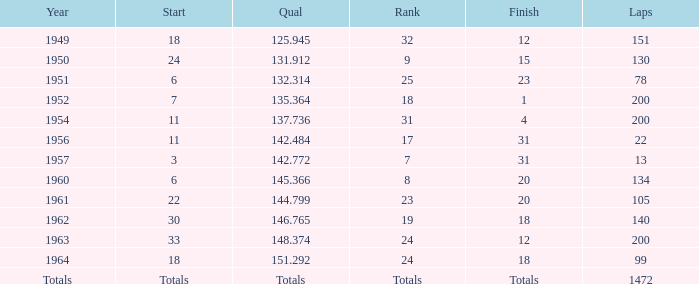Name the year for laps of 200 and rank of 24 1963.0. 